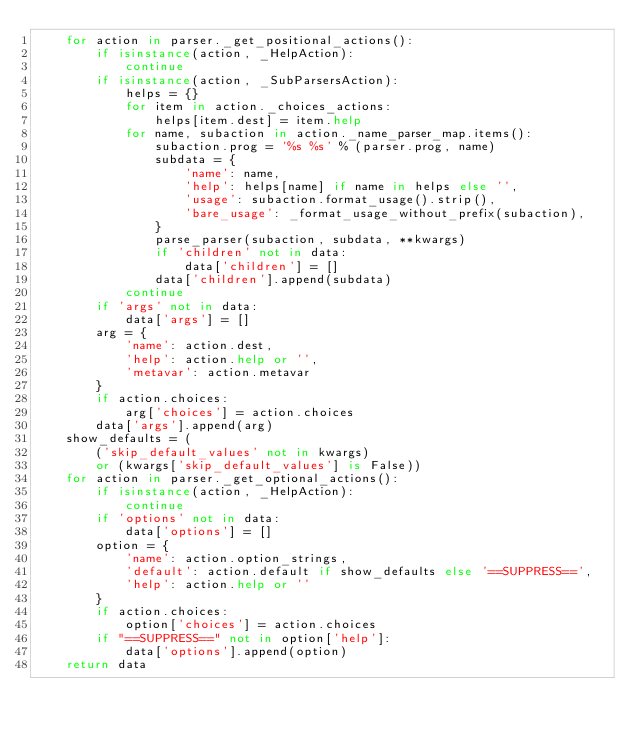<code> <loc_0><loc_0><loc_500><loc_500><_Python_>    for action in parser._get_positional_actions():
        if isinstance(action, _HelpAction):
            continue
        if isinstance(action, _SubParsersAction):
            helps = {}
            for item in action._choices_actions:
                helps[item.dest] = item.help
            for name, subaction in action._name_parser_map.items():
                subaction.prog = '%s %s' % (parser.prog, name)
                subdata = {
                    'name': name,
                    'help': helps[name] if name in helps else '',
                    'usage': subaction.format_usage().strip(),
                    'bare_usage': _format_usage_without_prefix(subaction),
                }
                parse_parser(subaction, subdata, **kwargs)
                if 'children' not in data:
                    data['children'] = []
                data['children'].append(subdata)
            continue
        if 'args' not in data:
            data['args'] = []
        arg = {
            'name': action.dest,
            'help': action.help or '',
            'metavar': action.metavar
        }
        if action.choices:
            arg['choices'] = action.choices
        data['args'].append(arg)
    show_defaults = (
        ('skip_default_values' not in kwargs)
        or (kwargs['skip_default_values'] is False))
    for action in parser._get_optional_actions():
        if isinstance(action, _HelpAction):
            continue
        if 'options' not in data:
            data['options'] = []
        option = {
            'name': action.option_strings,
            'default': action.default if show_defaults else '==SUPPRESS==',
            'help': action.help or ''
        }
        if action.choices:
            option['choices'] = action.choices
        if "==SUPPRESS==" not in option['help']:
            data['options'].append(option)
    return data
</code> 